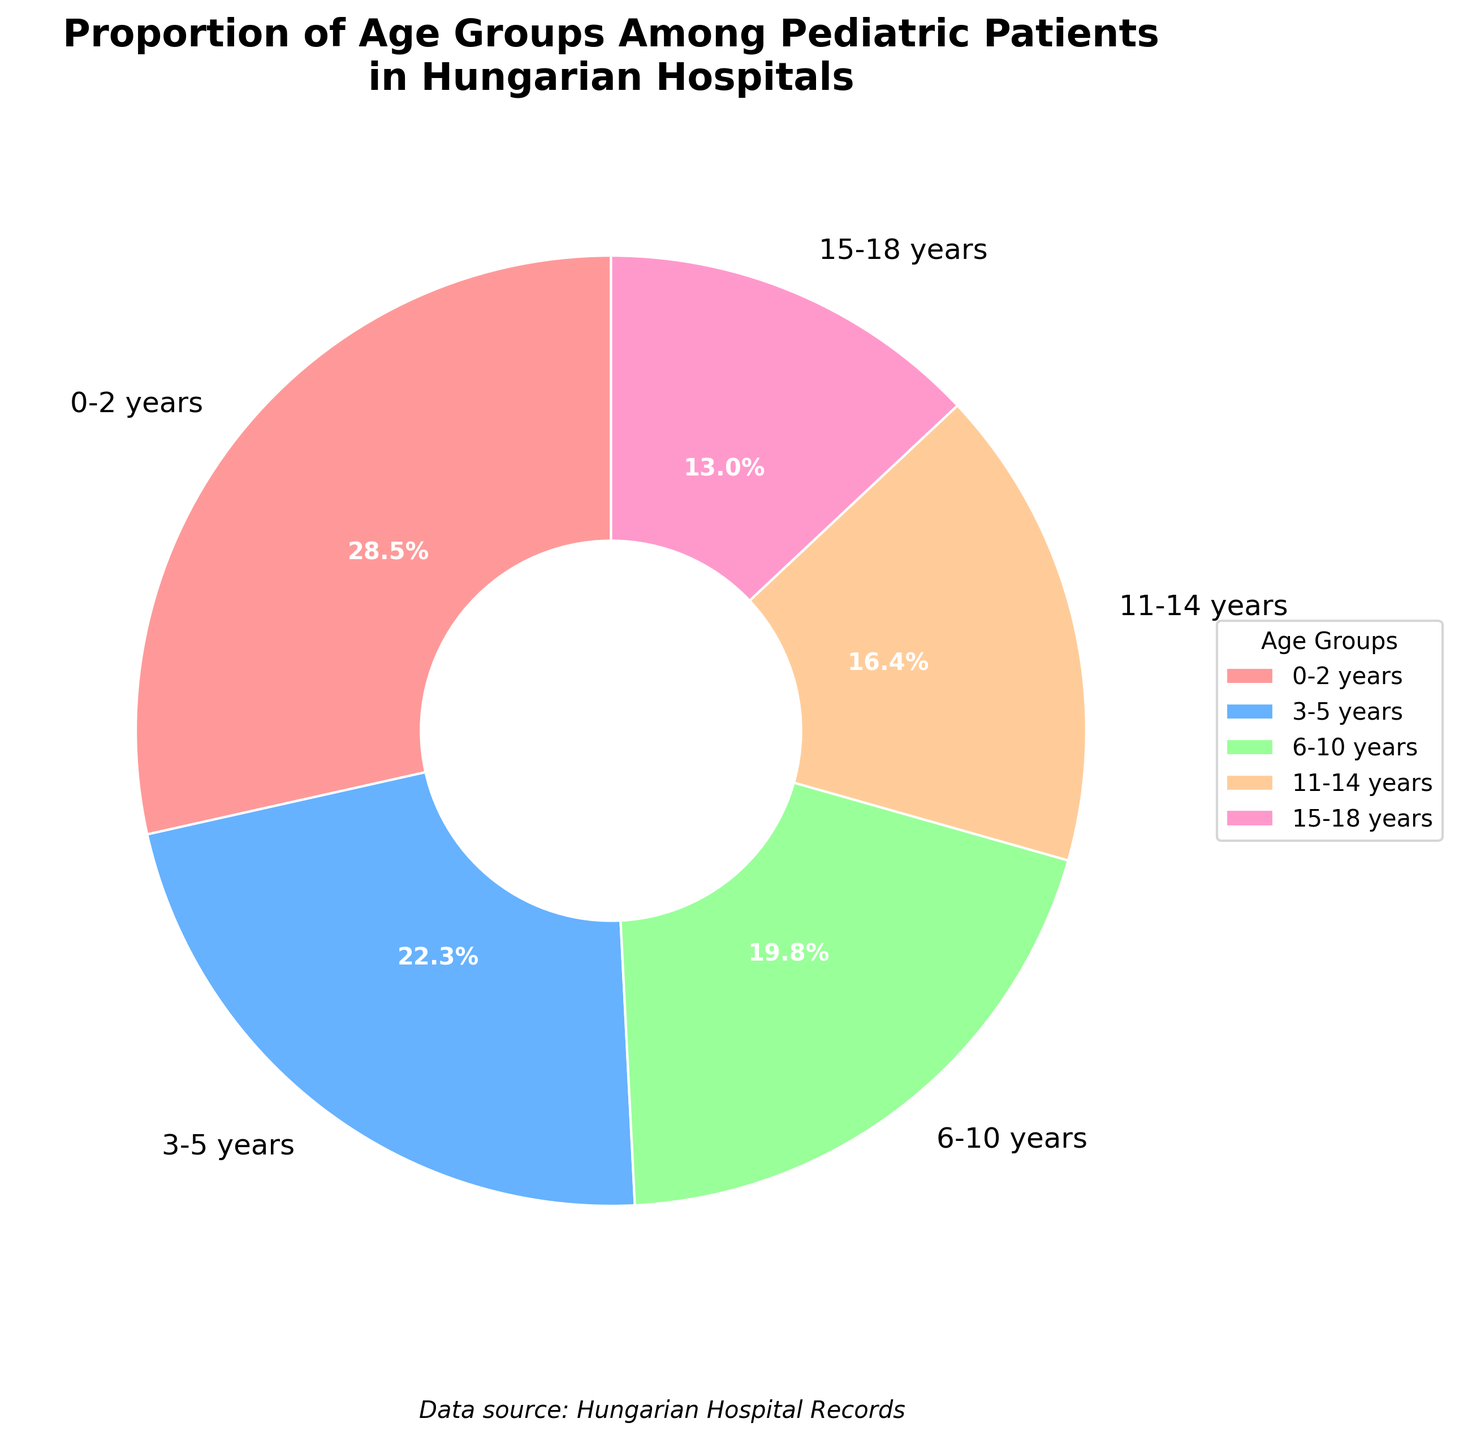Which age group has the highest proportion of patients? The pie chart shows the different age groups and their corresponding percentages. The age group with the highest percentage is at the top left corner of the chart. The age group "0-2 years" has the highest proportion at 28.5%.
Answer: 0-2 years Which age group has the lowest proportion of patients? According to the pie chart, the age group with the smallest slice is the one with the lowest percentage. The "15-18 years" age group has the lowest proportion at 13.0%.
Answer: 15-18 years Are the combined proportions of ages 0-2 years and 3-5 years greater than 50%? Sum the percentages of the age groups "0-2 years" and "3-5 years". That is 28.5% + 22.3% = 50.8%, which is greater than 50%.
Answer: Yes Which age group has nearly equal proportion to the 11-14 years group? Look at the percentages for the age groups to find one that is close to the "11-14 years" group, which has 16.4%. The "15-18 years" group with 13.0% is the closest.
Answer: 15-18 years By how much does the 6-10 years group's proportion exceed the 15-18 years group's? Find the difference between the percentages for the "6-10 years" group and the "15-18 years" group. That is 19.8% - 13.0% = 6.8%.
Answer: 6.8% What is the total proportion of patients aged 6-18 years? Sum the percentages for the "6-10 years," "11-14 years," and "15-18 years" groups. That is 19.8% + 16.4% + 13.0% = 49.2%.
Answer: 49.2% Which color represents the 3-5 years age group? Refer to the legend or the pie chart slices to see what color is assigned to the "3-5 years" group. The "3-5 years" group is represented by the blue slice.
Answer: Blue 